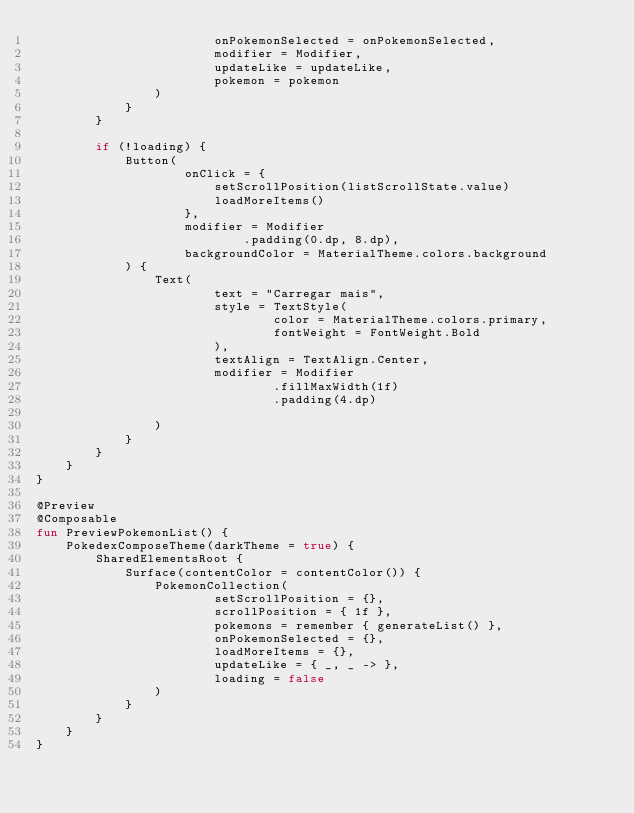Convert code to text. <code><loc_0><loc_0><loc_500><loc_500><_Kotlin_>                        onPokemonSelected = onPokemonSelected,
                        modifier = Modifier,
                        updateLike = updateLike,
                        pokemon = pokemon
                )
            }
        }

        if (!loading) {
            Button(
                    onClick = {
                        setScrollPosition(listScrollState.value)
                        loadMoreItems()
                    },
                    modifier = Modifier
                            .padding(0.dp, 8.dp),
                    backgroundColor = MaterialTheme.colors.background
            ) {
                Text(
                        text = "Carregar mais",
                        style = TextStyle(
                                color = MaterialTheme.colors.primary,
                                fontWeight = FontWeight.Bold
                        ),
                        textAlign = TextAlign.Center,
                        modifier = Modifier
                                .fillMaxWidth(1f)
                                .padding(4.dp)

                )
            }
        }
    }
}

@Preview
@Composable
fun PreviewPokemonList() {
    PokedexComposeTheme(darkTheme = true) {
        SharedElementsRoot {
            Surface(contentColor = contentColor()) {
                PokemonCollection(
                        setScrollPosition = {},
                        scrollPosition = { 1f },
                        pokemons = remember { generateList() },
                        onPokemonSelected = {},
                        loadMoreItems = {},
                        updateLike = { _, _ -> },
                        loading = false
                )
            }
        }
    }
}
</code> 